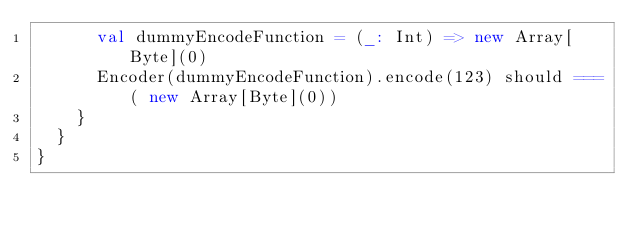<code> <loc_0><loc_0><loc_500><loc_500><_Scala_>      val dummyEncodeFunction = (_: Int) => new Array[Byte](0)
      Encoder(dummyEncodeFunction).encode(123) should ===( new Array[Byte](0))
    }
  }
}</code> 